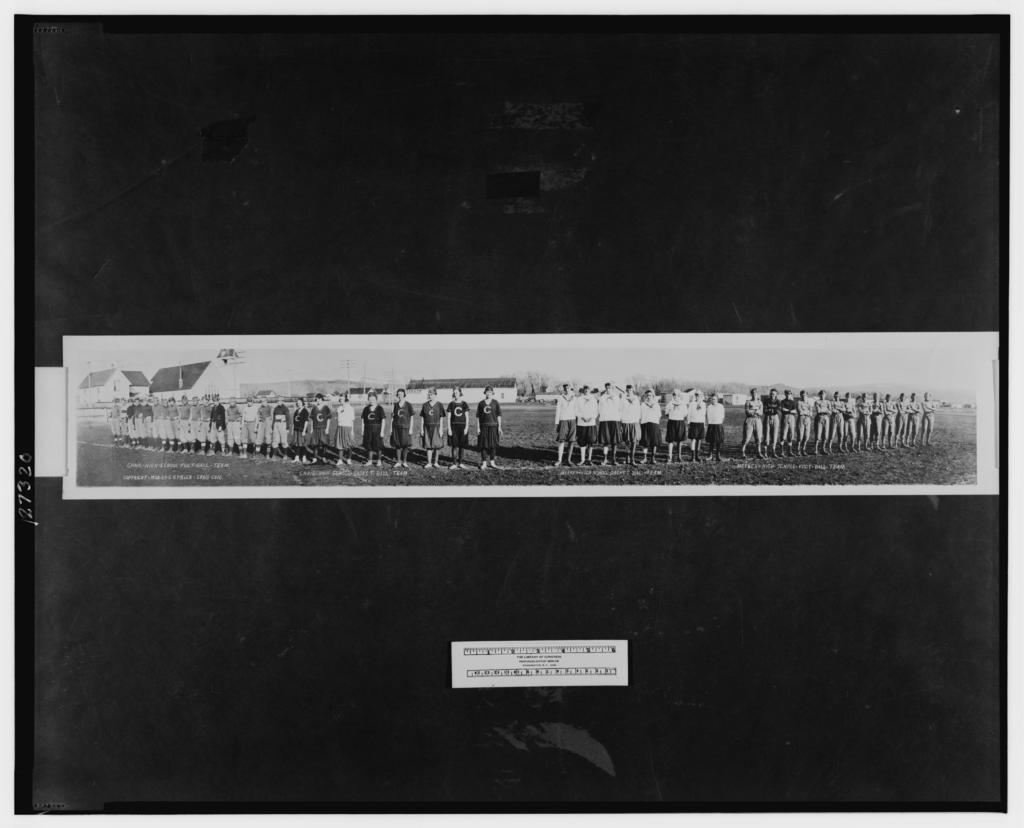What is the main subject of the photo? The main subject of the photo is a group of persons. Can you describe any additional elements in the photo? There is a sticker stuck to the wall in the photo. What type of store can be seen in the background of the photo? There is no store visible in the photo; it only shows a group of persons and a sticker on the wall. 